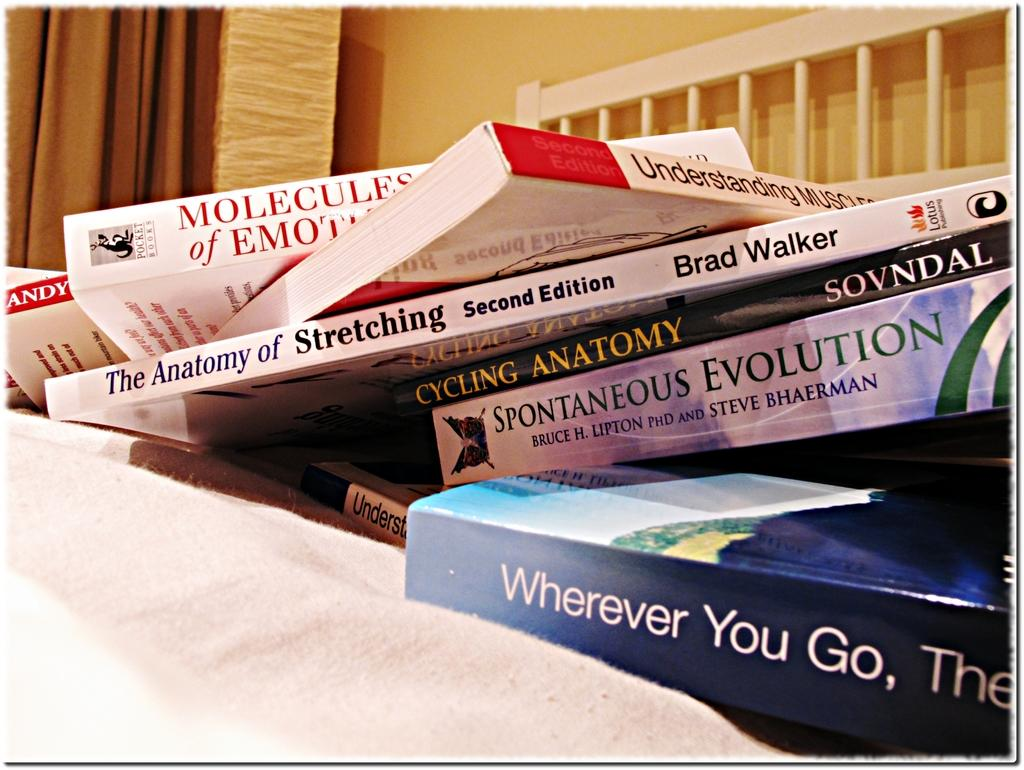<image>
Provide a brief description of the given image. Books laying on a bed with one entitled Wherever You Go 